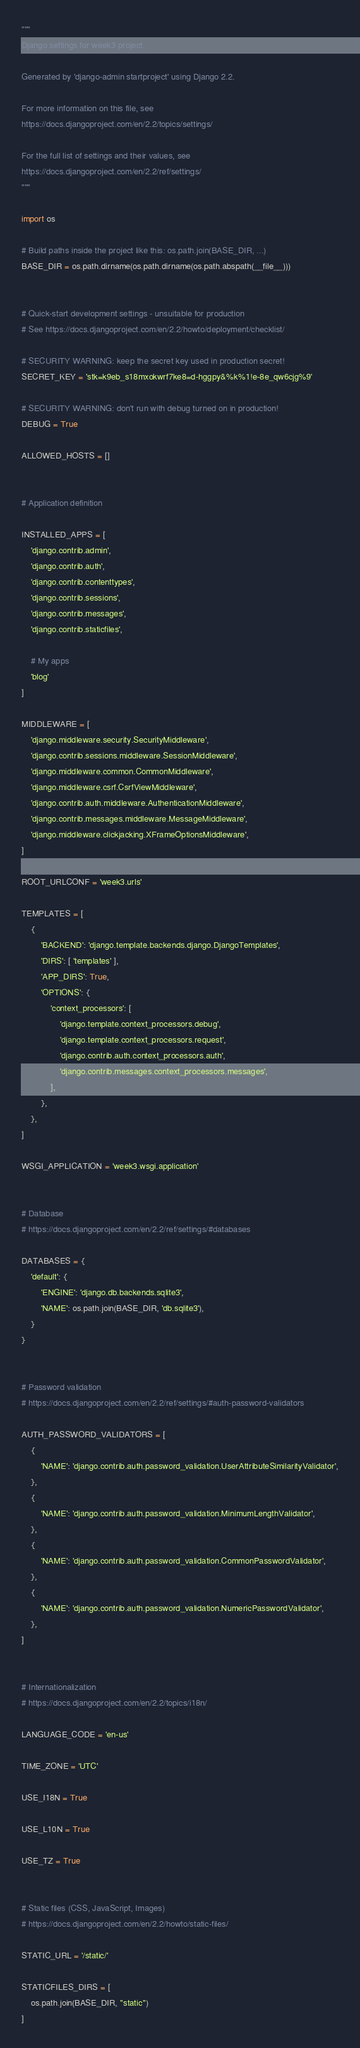<code> <loc_0><loc_0><loc_500><loc_500><_Python_>"""
Django settings for week3 project.

Generated by 'django-admin startproject' using Django 2.2.

For more information on this file, see
https://docs.djangoproject.com/en/2.2/topics/settings/

For the full list of settings and their values, see
https://docs.djangoproject.com/en/2.2/ref/settings/
"""

import os

# Build paths inside the project like this: os.path.join(BASE_DIR, ...)
BASE_DIR = os.path.dirname(os.path.dirname(os.path.abspath(__file__)))


# Quick-start development settings - unsuitable for production
# See https://docs.djangoproject.com/en/2.2/howto/deployment/checklist/

# SECURITY WARNING: keep the secret key used in production secret!
SECRET_KEY = 'stk=k9eb_s18mxokwrf7ke8=d-hggpy&%k%1!e-8e_qw6cjg%9'

# SECURITY WARNING: don't run with debug turned on in production!
DEBUG = True

ALLOWED_HOSTS = []


# Application definition

INSTALLED_APPS = [
    'django.contrib.admin',
    'django.contrib.auth',
    'django.contrib.contenttypes',
    'django.contrib.sessions',
    'django.contrib.messages',
    'django.contrib.staticfiles',

    # My apps
    'blog'
]

MIDDLEWARE = [
    'django.middleware.security.SecurityMiddleware',
    'django.contrib.sessions.middleware.SessionMiddleware',
    'django.middleware.common.CommonMiddleware',
    'django.middleware.csrf.CsrfViewMiddleware',
    'django.contrib.auth.middleware.AuthenticationMiddleware',
    'django.contrib.messages.middleware.MessageMiddleware',
    'django.middleware.clickjacking.XFrameOptionsMiddleware',
]

ROOT_URLCONF = 'week3.urls'

TEMPLATES = [
    {
        'BACKEND': 'django.template.backends.django.DjangoTemplates',
        'DIRS': [ 'templates' ],
        'APP_DIRS': True,
        'OPTIONS': {
            'context_processors': [
                'django.template.context_processors.debug',
                'django.template.context_processors.request',
                'django.contrib.auth.context_processors.auth',
                'django.contrib.messages.context_processors.messages',
            ],
        },
    },
]

WSGI_APPLICATION = 'week3.wsgi.application'


# Database
# https://docs.djangoproject.com/en/2.2/ref/settings/#databases

DATABASES = {
    'default': {
        'ENGINE': 'django.db.backends.sqlite3',
        'NAME': os.path.join(BASE_DIR, 'db.sqlite3'),
    }
}


# Password validation
# https://docs.djangoproject.com/en/2.2/ref/settings/#auth-password-validators

AUTH_PASSWORD_VALIDATORS = [
    {
        'NAME': 'django.contrib.auth.password_validation.UserAttributeSimilarityValidator',
    },
    {
        'NAME': 'django.contrib.auth.password_validation.MinimumLengthValidator',
    },
    {
        'NAME': 'django.contrib.auth.password_validation.CommonPasswordValidator',
    },
    {
        'NAME': 'django.contrib.auth.password_validation.NumericPasswordValidator',
    },
]


# Internationalization
# https://docs.djangoproject.com/en/2.2/topics/i18n/

LANGUAGE_CODE = 'en-us'

TIME_ZONE = 'UTC'

USE_I18N = True

USE_L10N = True

USE_TZ = True


# Static files (CSS, JavaScript, Images)
# https://docs.djangoproject.com/en/2.2/howto/static-files/

STATIC_URL = '/static/'

STATICFILES_DIRS = [
    os.path.join(BASE_DIR, "static")
]</code> 